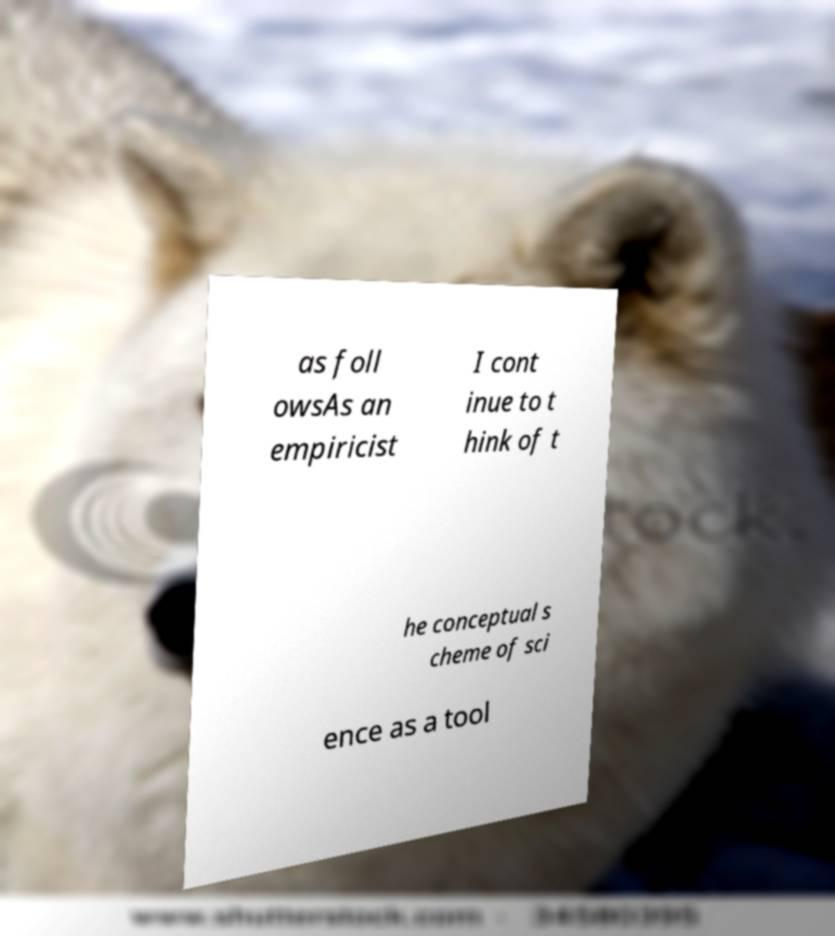What messages or text are displayed in this image? I need them in a readable, typed format. as foll owsAs an empiricist I cont inue to t hink of t he conceptual s cheme of sci ence as a tool 